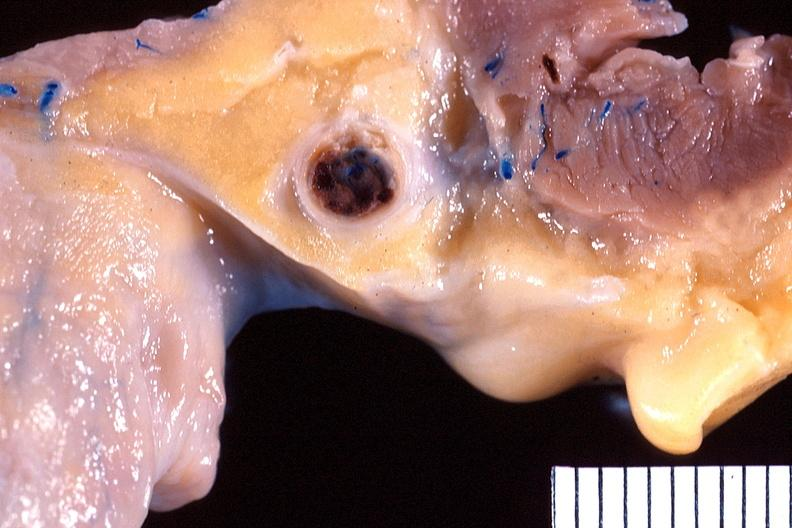s cardiovascular present?
Answer the question using a single word or phrase. Yes 